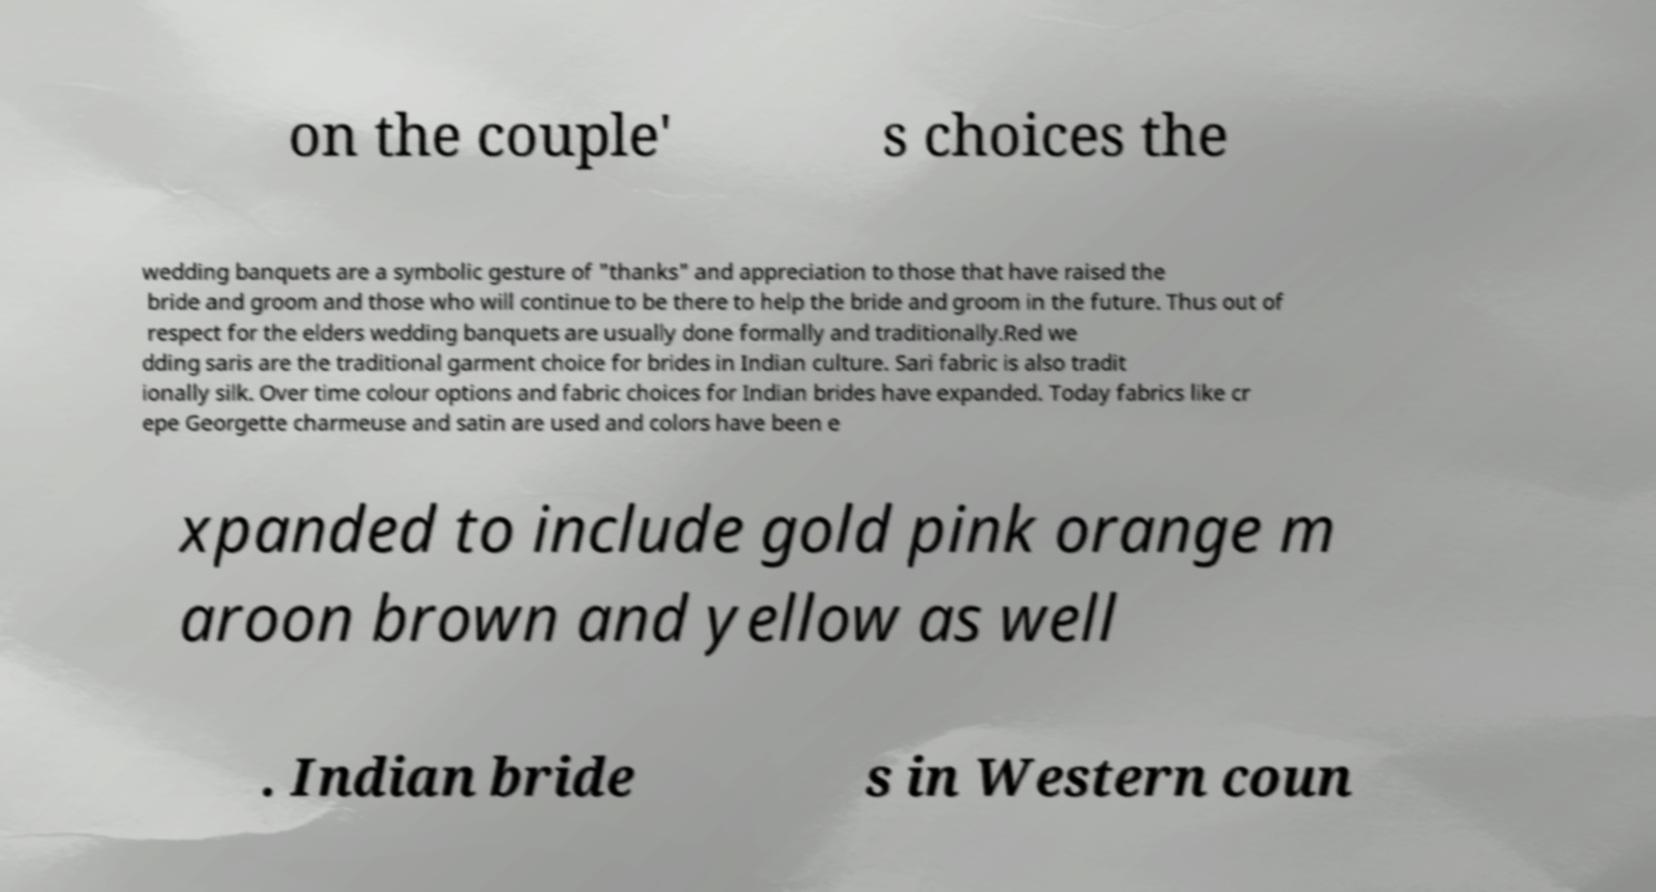For documentation purposes, I need the text within this image transcribed. Could you provide that? on the couple' s choices the wedding banquets are a symbolic gesture of "thanks" and appreciation to those that have raised the bride and groom and those who will continue to be there to help the bride and groom in the future. Thus out of respect for the elders wedding banquets are usually done formally and traditionally.Red we dding saris are the traditional garment choice for brides in Indian culture. Sari fabric is also tradit ionally silk. Over time colour options and fabric choices for Indian brides have expanded. Today fabrics like cr epe Georgette charmeuse and satin are used and colors have been e xpanded to include gold pink orange m aroon brown and yellow as well . Indian bride s in Western coun 